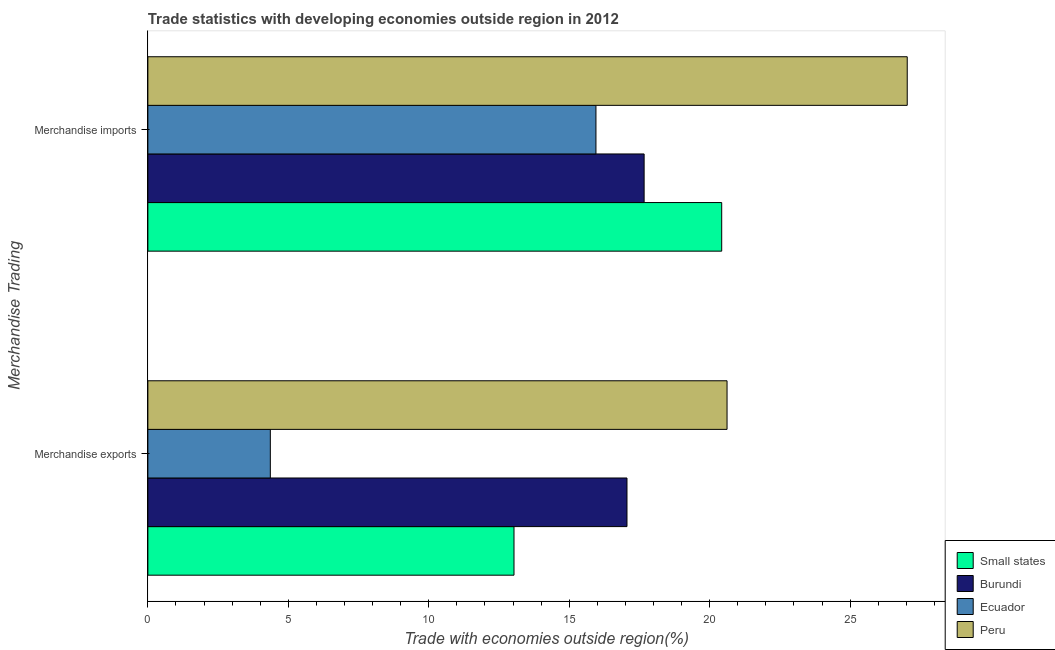Are the number of bars per tick equal to the number of legend labels?
Make the answer very short. Yes. What is the label of the 2nd group of bars from the top?
Keep it short and to the point. Merchandise exports. What is the merchandise imports in Peru?
Your answer should be very brief. 27.03. Across all countries, what is the maximum merchandise imports?
Your answer should be compact. 27.03. Across all countries, what is the minimum merchandise exports?
Your answer should be very brief. 4.36. In which country was the merchandise imports minimum?
Offer a very short reply. Ecuador. What is the total merchandise exports in the graph?
Provide a short and direct response. 55.07. What is the difference between the merchandise exports in Burundi and that in Small states?
Offer a very short reply. 4.02. What is the difference between the merchandise exports in Burundi and the merchandise imports in Small states?
Keep it short and to the point. -3.37. What is the average merchandise exports per country?
Provide a succinct answer. 13.77. What is the difference between the merchandise imports and merchandise exports in Small states?
Give a very brief answer. 7.39. In how many countries, is the merchandise exports greater than 5 %?
Keep it short and to the point. 3. What is the ratio of the merchandise imports in Peru to that in Burundi?
Offer a terse response. 1.53. What does the 3rd bar from the top in Merchandise imports represents?
Your response must be concise. Burundi. What does the 2nd bar from the bottom in Merchandise imports represents?
Offer a very short reply. Burundi. Are all the bars in the graph horizontal?
Offer a very short reply. Yes. How many countries are there in the graph?
Your answer should be very brief. 4. Does the graph contain any zero values?
Provide a succinct answer. No. How many legend labels are there?
Offer a terse response. 4. What is the title of the graph?
Provide a succinct answer. Trade statistics with developing economies outside region in 2012. What is the label or title of the X-axis?
Keep it short and to the point. Trade with economies outside region(%). What is the label or title of the Y-axis?
Your answer should be very brief. Merchandise Trading. What is the Trade with economies outside region(%) in Small states in Merchandise exports?
Your answer should be very brief. 13.03. What is the Trade with economies outside region(%) of Burundi in Merchandise exports?
Keep it short and to the point. 17.06. What is the Trade with economies outside region(%) in Ecuador in Merchandise exports?
Give a very brief answer. 4.36. What is the Trade with economies outside region(%) of Peru in Merchandise exports?
Your answer should be very brief. 20.62. What is the Trade with economies outside region(%) of Small states in Merchandise imports?
Ensure brevity in your answer.  20.43. What is the Trade with economies outside region(%) of Burundi in Merchandise imports?
Provide a short and direct response. 17.67. What is the Trade with economies outside region(%) in Ecuador in Merchandise imports?
Offer a very short reply. 15.95. What is the Trade with economies outside region(%) of Peru in Merchandise imports?
Keep it short and to the point. 27.03. Across all Merchandise Trading, what is the maximum Trade with economies outside region(%) in Small states?
Provide a short and direct response. 20.43. Across all Merchandise Trading, what is the maximum Trade with economies outside region(%) in Burundi?
Keep it short and to the point. 17.67. Across all Merchandise Trading, what is the maximum Trade with economies outside region(%) of Ecuador?
Provide a short and direct response. 15.95. Across all Merchandise Trading, what is the maximum Trade with economies outside region(%) of Peru?
Give a very brief answer. 27.03. Across all Merchandise Trading, what is the minimum Trade with economies outside region(%) in Small states?
Offer a very short reply. 13.03. Across all Merchandise Trading, what is the minimum Trade with economies outside region(%) in Burundi?
Provide a succinct answer. 17.06. Across all Merchandise Trading, what is the minimum Trade with economies outside region(%) in Ecuador?
Give a very brief answer. 4.36. Across all Merchandise Trading, what is the minimum Trade with economies outside region(%) in Peru?
Your answer should be very brief. 20.62. What is the total Trade with economies outside region(%) in Small states in the graph?
Make the answer very short. 33.46. What is the total Trade with economies outside region(%) of Burundi in the graph?
Your answer should be very brief. 34.72. What is the total Trade with economies outside region(%) of Ecuador in the graph?
Offer a very short reply. 20.31. What is the total Trade with economies outside region(%) of Peru in the graph?
Your answer should be compact. 47.65. What is the difference between the Trade with economies outside region(%) of Small states in Merchandise exports and that in Merchandise imports?
Make the answer very short. -7.39. What is the difference between the Trade with economies outside region(%) of Burundi in Merchandise exports and that in Merchandise imports?
Provide a succinct answer. -0.61. What is the difference between the Trade with economies outside region(%) of Ecuador in Merchandise exports and that in Merchandise imports?
Your answer should be very brief. -11.59. What is the difference between the Trade with economies outside region(%) in Peru in Merchandise exports and that in Merchandise imports?
Ensure brevity in your answer.  -6.41. What is the difference between the Trade with economies outside region(%) in Small states in Merchandise exports and the Trade with economies outside region(%) in Burundi in Merchandise imports?
Provide a short and direct response. -4.63. What is the difference between the Trade with economies outside region(%) in Small states in Merchandise exports and the Trade with economies outside region(%) in Ecuador in Merchandise imports?
Make the answer very short. -2.92. What is the difference between the Trade with economies outside region(%) in Small states in Merchandise exports and the Trade with economies outside region(%) in Peru in Merchandise imports?
Provide a short and direct response. -14. What is the difference between the Trade with economies outside region(%) of Burundi in Merchandise exports and the Trade with economies outside region(%) of Ecuador in Merchandise imports?
Make the answer very short. 1.1. What is the difference between the Trade with economies outside region(%) in Burundi in Merchandise exports and the Trade with economies outside region(%) in Peru in Merchandise imports?
Ensure brevity in your answer.  -9.98. What is the difference between the Trade with economies outside region(%) in Ecuador in Merchandise exports and the Trade with economies outside region(%) in Peru in Merchandise imports?
Provide a short and direct response. -22.67. What is the average Trade with economies outside region(%) of Small states per Merchandise Trading?
Your response must be concise. 16.73. What is the average Trade with economies outside region(%) of Burundi per Merchandise Trading?
Keep it short and to the point. 17.36. What is the average Trade with economies outside region(%) of Ecuador per Merchandise Trading?
Ensure brevity in your answer.  10.16. What is the average Trade with economies outside region(%) of Peru per Merchandise Trading?
Provide a succinct answer. 23.83. What is the difference between the Trade with economies outside region(%) in Small states and Trade with economies outside region(%) in Burundi in Merchandise exports?
Your answer should be very brief. -4.02. What is the difference between the Trade with economies outside region(%) of Small states and Trade with economies outside region(%) of Ecuador in Merchandise exports?
Offer a terse response. 8.67. What is the difference between the Trade with economies outside region(%) in Small states and Trade with economies outside region(%) in Peru in Merchandise exports?
Make the answer very short. -7.58. What is the difference between the Trade with economies outside region(%) of Burundi and Trade with economies outside region(%) of Ecuador in Merchandise exports?
Keep it short and to the point. 12.7. What is the difference between the Trade with economies outside region(%) of Burundi and Trade with economies outside region(%) of Peru in Merchandise exports?
Your response must be concise. -3.56. What is the difference between the Trade with economies outside region(%) of Ecuador and Trade with economies outside region(%) of Peru in Merchandise exports?
Offer a terse response. -16.26. What is the difference between the Trade with economies outside region(%) of Small states and Trade with economies outside region(%) of Burundi in Merchandise imports?
Offer a very short reply. 2.76. What is the difference between the Trade with economies outside region(%) in Small states and Trade with economies outside region(%) in Ecuador in Merchandise imports?
Make the answer very short. 4.48. What is the difference between the Trade with economies outside region(%) of Small states and Trade with economies outside region(%) of Peru in Merchandise imports?
Your answer should be compact. -6.6. What is the difference between the Trade with economies outside region(%) in Burundi and Trade with economies outside region(%) in Ecuador in Merchandise imports?
Provide a succinct answer. 1.72. What is the difference between the Trade with economies outside region(%) of Burundi and Trade with economies outside region(%) of Peru in Merchandise imports?
Keep it short and to the point. -9.37. What is the difference between the Trade with economies outside region(%) in Ecuador and Trade with economies outside region(%) in Peru in Merchandise imports?
Your response must be concise. -11.08. What is the ratio of the Trade with economies outside region(%) in Small states in Merchandise exports to that in Merchandise imports?
Provide a short and direct response. 0.64. What is the ratio of the Trade with economies outside region(%) in Burundi in Merchandise exports to that in Merchandise imports?
Offer a terse response. 0.97. What is the ratio of the Trade with economies outside region(%) of Ecuador in Merchandise exports to that in Merchandise imports?
Ensure brevity in your answer.  0.27. What is the ratio of the Trade with economies outside region(%) in Peru in Merchandise exports to that in Merchandise imports?
Keep it short and to the point. 0.76. What is the difference between the highest and the second highest Trade with economies outside region(%) of Small states?
Provide a succinct answer. 7.39. What is the difference between the highest and the second highest Trade with economies outside region(%) in Burundi?
Your response must be concise. 0.61. What is the difference between the highest and the second highest Trade with economies outside region(%) of Ecuador?
Provide a succinct answer. 11.59. What is the difference between the highest and the second highest Trade with economies outside region(%) in Peru?
Your response must be concise. 6.41. What is the difference between the highest and the lowest Trade with economies outside region(%) in Small states?
Provide a succinct answer. 7.39. What is the difference between the highest and the lowest Trade with economies outside region(%) of Burundi?
Make the answer very short. 0.61. What is the difference between the highest and the lowest Trade with economies outside region(%) in Ecuador?
Keep it short and to the point. 11.59. What is the difference between the highest and the lowest Trade with economies outside region(%) in Peru?
Your answer should be very brief. 6.41. 